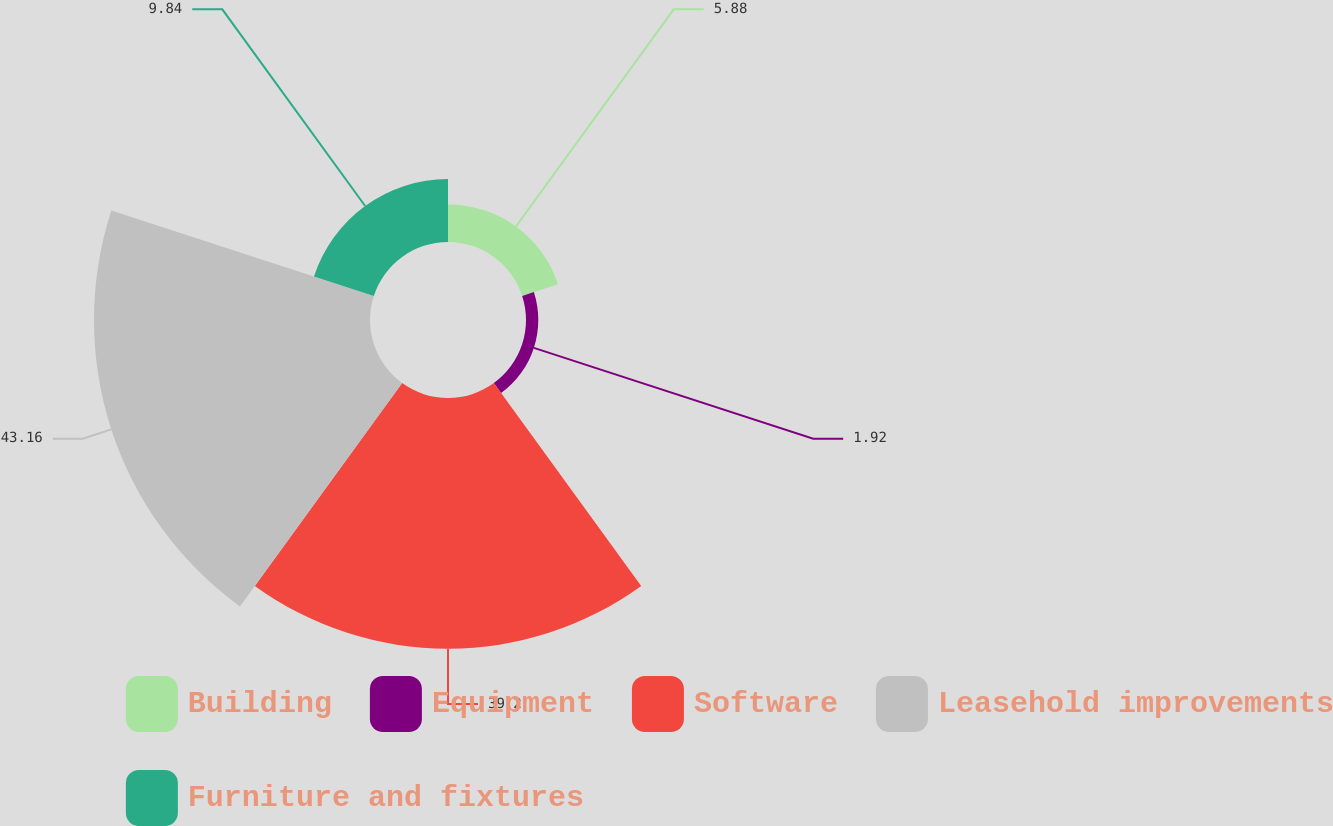Convert chart to OTSL. <chart><loc_0><loc_0><loc_500><loc_500><pie_chart><fcel>Building<fcel>Equipment<fcel>Software<fcel>Leasehold improvements<fcel>Furniture and fixtures<nl><fcel>5.88%<fcel>1.92%<fcel>39.2%<fcel>43.16%<fcel>9.84%<nl></chart> 